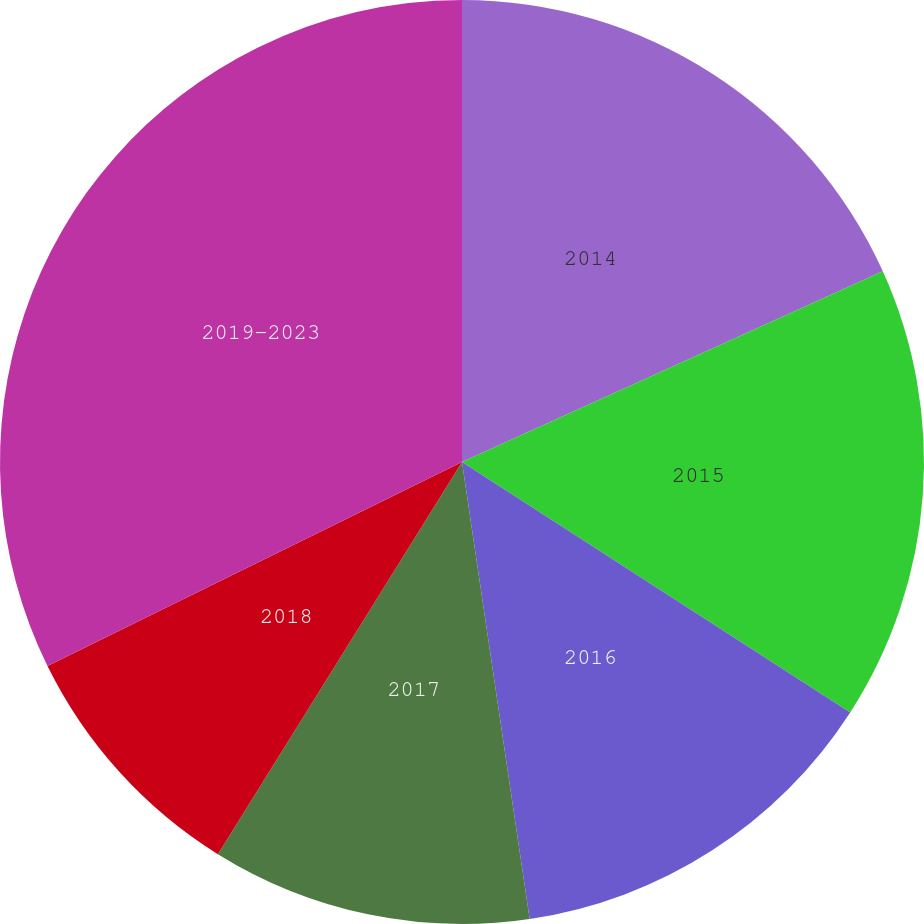<chart> <loc_0><loc_0><loc_500><loc_500><pie_chart><fcel>2014<fcel>2015<fcel>2016<fcel>2017<fcel>2018<fcel>2019-2023<nl><fcel>18.23%<fcel>15.89%<fcel>13.54%<fcel>11.2%<fcel>8.86%<fcel>32.28%<nl></chart> 